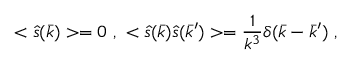<formula> <loc_0><loc_0><loc_500><loc_500>< \hat { s } ( \bar { k } ) > = 0 , < \hat { s } ( \bar { k } ) \hat { s } ( \bar { k } ^ { \prime } ) > = \frac { 1 } { k ^ { 3 } } \delta ( \bar { k } - \bar { k } ^ { \prime } ) ,</formula> 